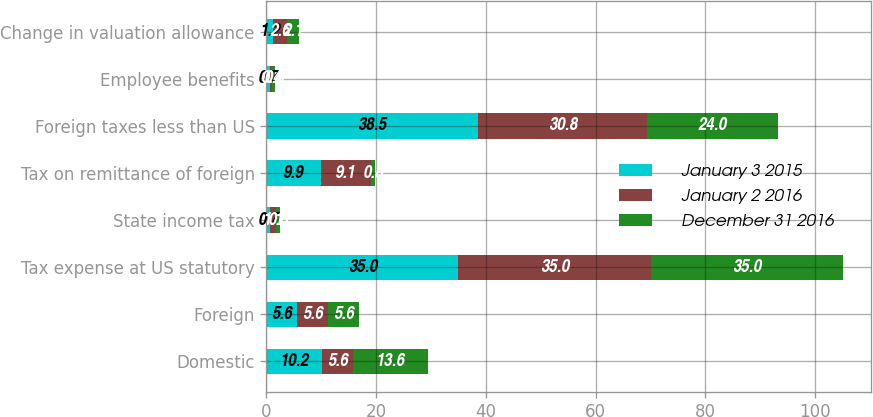Convert chart to OTSL. <chart><loc_0><loc_0><loc_500><loc_500><stacked_bar_chart><ecel><fcel>Domestic<fcel>Foreign<fcel>Tax expense at US statutory<fcel>State income tax<fcel>Tax on remittance of foreign<fcel>Foreign taxes less than US<fcel>Employee benefits<fcel>Change in valuation allowance<nl><fcel>January 3 2015<fcel>10.2<fcel>5.6<fcel>35<fcel>0.7<fcel>9.9<fcel>38.5<fcel>0.7<fcel>1.2<nl><fcel>January 2 2016<fcel>5.6<fcel>5.6<fcel>35<fcel>1.1<fcel>9.1<fcel>30.8<fcel>0.4<fcel>2.6<nl><fcel>December 31 2016<fcel>13.6<fcel>5.6<fcel>35<fcel>0.6<fcel>0.8<fcel>24<fcel>0.5<fcel>2.1<nl></chart> 